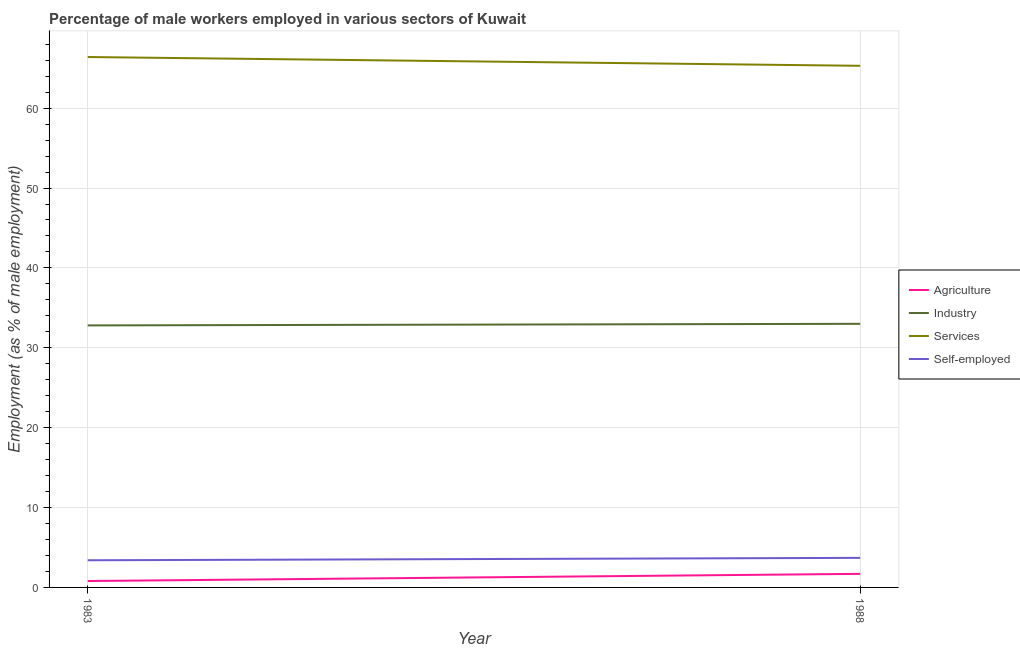How many different coloured lines are there?
Your answer should be compact. 4. Does the line corresponding to percentage of self employed male workers intersect with the line corresponding to percentage of male workers in agriculture?
Give a very brief answer. No. What is the percentage of male workers in agriculture in 1988?
Ensure brevity in your answer.  1.7. Across all years, what is the maximum percentage of male workers in agriculture?
Provide a succinct answer. 1.7. Across all years, what is the minimum percentage of male workers in services?
Your answer should be compact. 65.3. In which year was the percentage of male workers in industry maximum?
Offer a very short reply. 1988. In which year was the percentage of self employed male workers minimum?
Provide a short and direct response. 1983. What is the total percentage of male workers in agriculture in the graph?
Ensure brevity in your answer.  2.5. What is the difference between the percentage of self employed male workers in 1983 and that in 1988?
Your response must be concise. -0.3. What is the difference between the percentage of male workers in industry in 1988 and the percentage of self employed male workers in 1983?
Keep it short and to the point. 29.6. What is the average percentage of male workers in services per year?
Your response must be concise. 65.85. In the year 1988, what is the difference between the percentage of male workers in industry and percentage of self employed male workers?
Your answer should be compact. 29.3. What is the ratio of the percentage of male workers in agriculture in 1983 to that in 1988?
Offer a very short reply. 0.47. Is the percentage of male workers in agriculture in 1983 less than that in 1988?
Make the answer very short. Yes. In how many years, is the percentage of male workers in industry greater than the average percentage of male workers in industry taken over all years?
Give a very brief answer. 1. Is it the case that in every year, the sum of the percentage of male workers in industry and percentage of male workers in services is greater than the sum of percentage of male workers in agriculture and percentage of self employed male workers?
Offer a terse response. Yes. Does the percentage of male workers in services monotonically increase over the years?
Offer a terse response. No. Where does the legend appear in the graph?
Offer a very short reply. Center right. How are the legend labels stacked?
Provide a short and direct response. Vertical. What is the title of the graph?
Make the answer very short. Percentage of male workers employed in various sectors of Kuwait. What is the label or title of the Y-axis?
Ensure brevity in your answer.  Employment (as % of male employment). What is the Employment (as % of male employment) of Agriculture in 1983?
Your answer should be very brief. 0.8. What is the Employment (as % of male employment) in Industry in 1983?
Your answer should be very brief. 32.8. What is the Employment (as % of male employment) of Services in 1983?
Offer a very short reply. 66.4. What is the Employment (as % of male employment) of Self-employed in 1983?
Offer a terse response. 3.4. What is the Employment (as % of male employment) in Agriculture in 1988?
Offer a very short reply. 1.7. What is the Employment (as % of male employment) in Industry in 1988?
Your answer should be very brief. 33. What is the Employment (as % of male employment) in Services in 1988?
Give a very brief answer. 65.3. What is the Employment (as % of male employment) of Self-employed in 1988?
Give a very brief answer. 3.7. Across all years, what is the maximum Employment (as % of male employment) in Agriculture?
Your response must be concise. 1.7. Across all years, what is the maximum Employment (as % of male employment) in Services?
Offer a very short reply. 66.4. Across all years, what is the maximum Employment (as % of male employment) of Self-employed?
Offer a terse response. 3.7. Across all years, what is the minimum Employment (as % of male employment) in Agriculture?
Your response must be concise. 0.8. Across all years, what is the minimum Employment (as % of male employment) in Industry?
Offer a terse response. 32.8. Across all years, what is the minimum Employment (as % of male employment) of Services?
Make the answer very short. 65.3. Across all years, what is the minimum Employment (as % of male employment) in Self-employed?
Make the answer very short. 3.4. What is the total Employment (as % of male employment) in Industry in the graph?
Offer a terse response. 65.8. What is the total Employment (as % of male employment) in Services in the graph?
Ensure brevity in your answer.  131.7. What is the total Employment (as % of male employment) of Self-employed in the graph?
Give a very brief answer. 7.1. What is the difference between the Employment (as % of male employment) of Services in 1983 and that in 1988?
Your answer should be compact. 1.1. What is the difference between the Employment (as % of male employment) in Agriculture in 1983 and the Employment (as % of male employment) in Industry in 1988?
Your response must be concise. -32.2. What is the difference between the Employment (as % of male employment) of Agriculture in 1983 and the Employment (as % of male employment) of Services in 1988?
Offer a terse response. -64.5. What is the difference between the Employment (as % of male employment) in Agriculture in 1983 and the Employment (as % of male employment) in Self-employed in 1988?
Provide a short and direct response. -2.9. What is the difference between the Employment (as % of male employment) of Industry in 1983 and the Employment (as % of male employment) of Services in 1988?
Give a very brief answer. -32.5. What is the difference between the Employment (as % of male employment) of Industry in 1983 and the Employment (as % of male employment) of Self-employed in 1988?
Provide a succinct answer. 29.1. What is the difference between the Employment (as % of male employment) in Services in 1983 and the Employment (as % of male employment) in Self-employed in 1988?
Keep it short and to the point. 62.7. What is the average Employment (as % of male employment) of Industry per year?
Your response must be concise. 32.9. What is the average Employment (as % of male employment) in Services per year?
Your answer should be very brief. 65.85. What is the average Employment (as % of male employment) of Self-employed per year?
Your answer should be very brief. 3.55. In the year 1983, what is the difference between the Employment (as % of male employment) in Agriculture and Employment (as % of male employment) in Industry?
Offer a terse response. -32. In the year 1983, what is the difference between the Employment (as % of male employment) in Agriculture and Employment (as % of male employment) in Services?
Give a very brief answer. -65.6. In the year 1983, what is the difference between the Employment (as % of male employment) in Industry and Employment (as % of male employment) in Services?
Give a very brief answer. -33.6. In the year 1983, what is the difference between the Employment (as % of male employment) of Industry and Employment (as % of male employment) of Self-employed?
Make the answer very short. 29.4. In the year 1983, what is the difference between the Employment (as % of male employment) in Services and Employment (as % of male employment) in Self-employed?
Your answer should be compact. 63. In the year 1988, what is the difference between the Employment (as % of male employment) of Agriculture and Employment (as % of male employment) of Industry?
Keep it short and to the point. -31.3. In the year 1988, what is the difference between the Employment (as % of male employment) in Agriculture and Employment (as % of male employment) in Services?
Provide a succinct answer. -63.6. In the year 1988, what is the difference between the Employment (as % of male employment) in Industry and Employment (as % of male employment) in Services?
Give a very brief answer. -32.3. In the year 1988, what is the difference between the Employment (as % of male employment) of Industry and Employment (as % of male employment) of Self-employed?
Keep it short and to the point. 29.3. In the year 1988, what is the difference between the Employment (as % of male employment) of Services and Employment (as % of male employment) of Self-employed?
Offer a very short reply. 61.6. What is the ratio of the Employment (as % of male employment) of Agriculture in 1983 to that in 1988?
Provide a short and direct response. 0.47. What is the ratio of the Employment (as % of male employment) in Industry in 1983 to that in 1988?
Your response must be concise. 0.99. What is the ratio of the Employment (as % of male employment) in Services in 1983 to that in 1988?
Your answer should be compact. 1.02. What is the ratio of the Employment (as % of male employment) of Self-employed in 1983 to that in 1988?
Give a very brief answer. 0.92. What is the difference between the highest and the second highest Employment (as % of male employment) of Industry?
Provide a short and direct response. 0.2. What is the difference between the highest and the lowest Employment (as % of male employment) of Agriculture?
Keep it short and to the point. 0.9. What is the difference between the highest and the lowest Employment (as % of male employment) of Industry?
Your answer should be compact. 0.2. What is the difference between the highest and the lowest Employment (as % of male employment) of Services?
Your response must be concise. 1.1. 